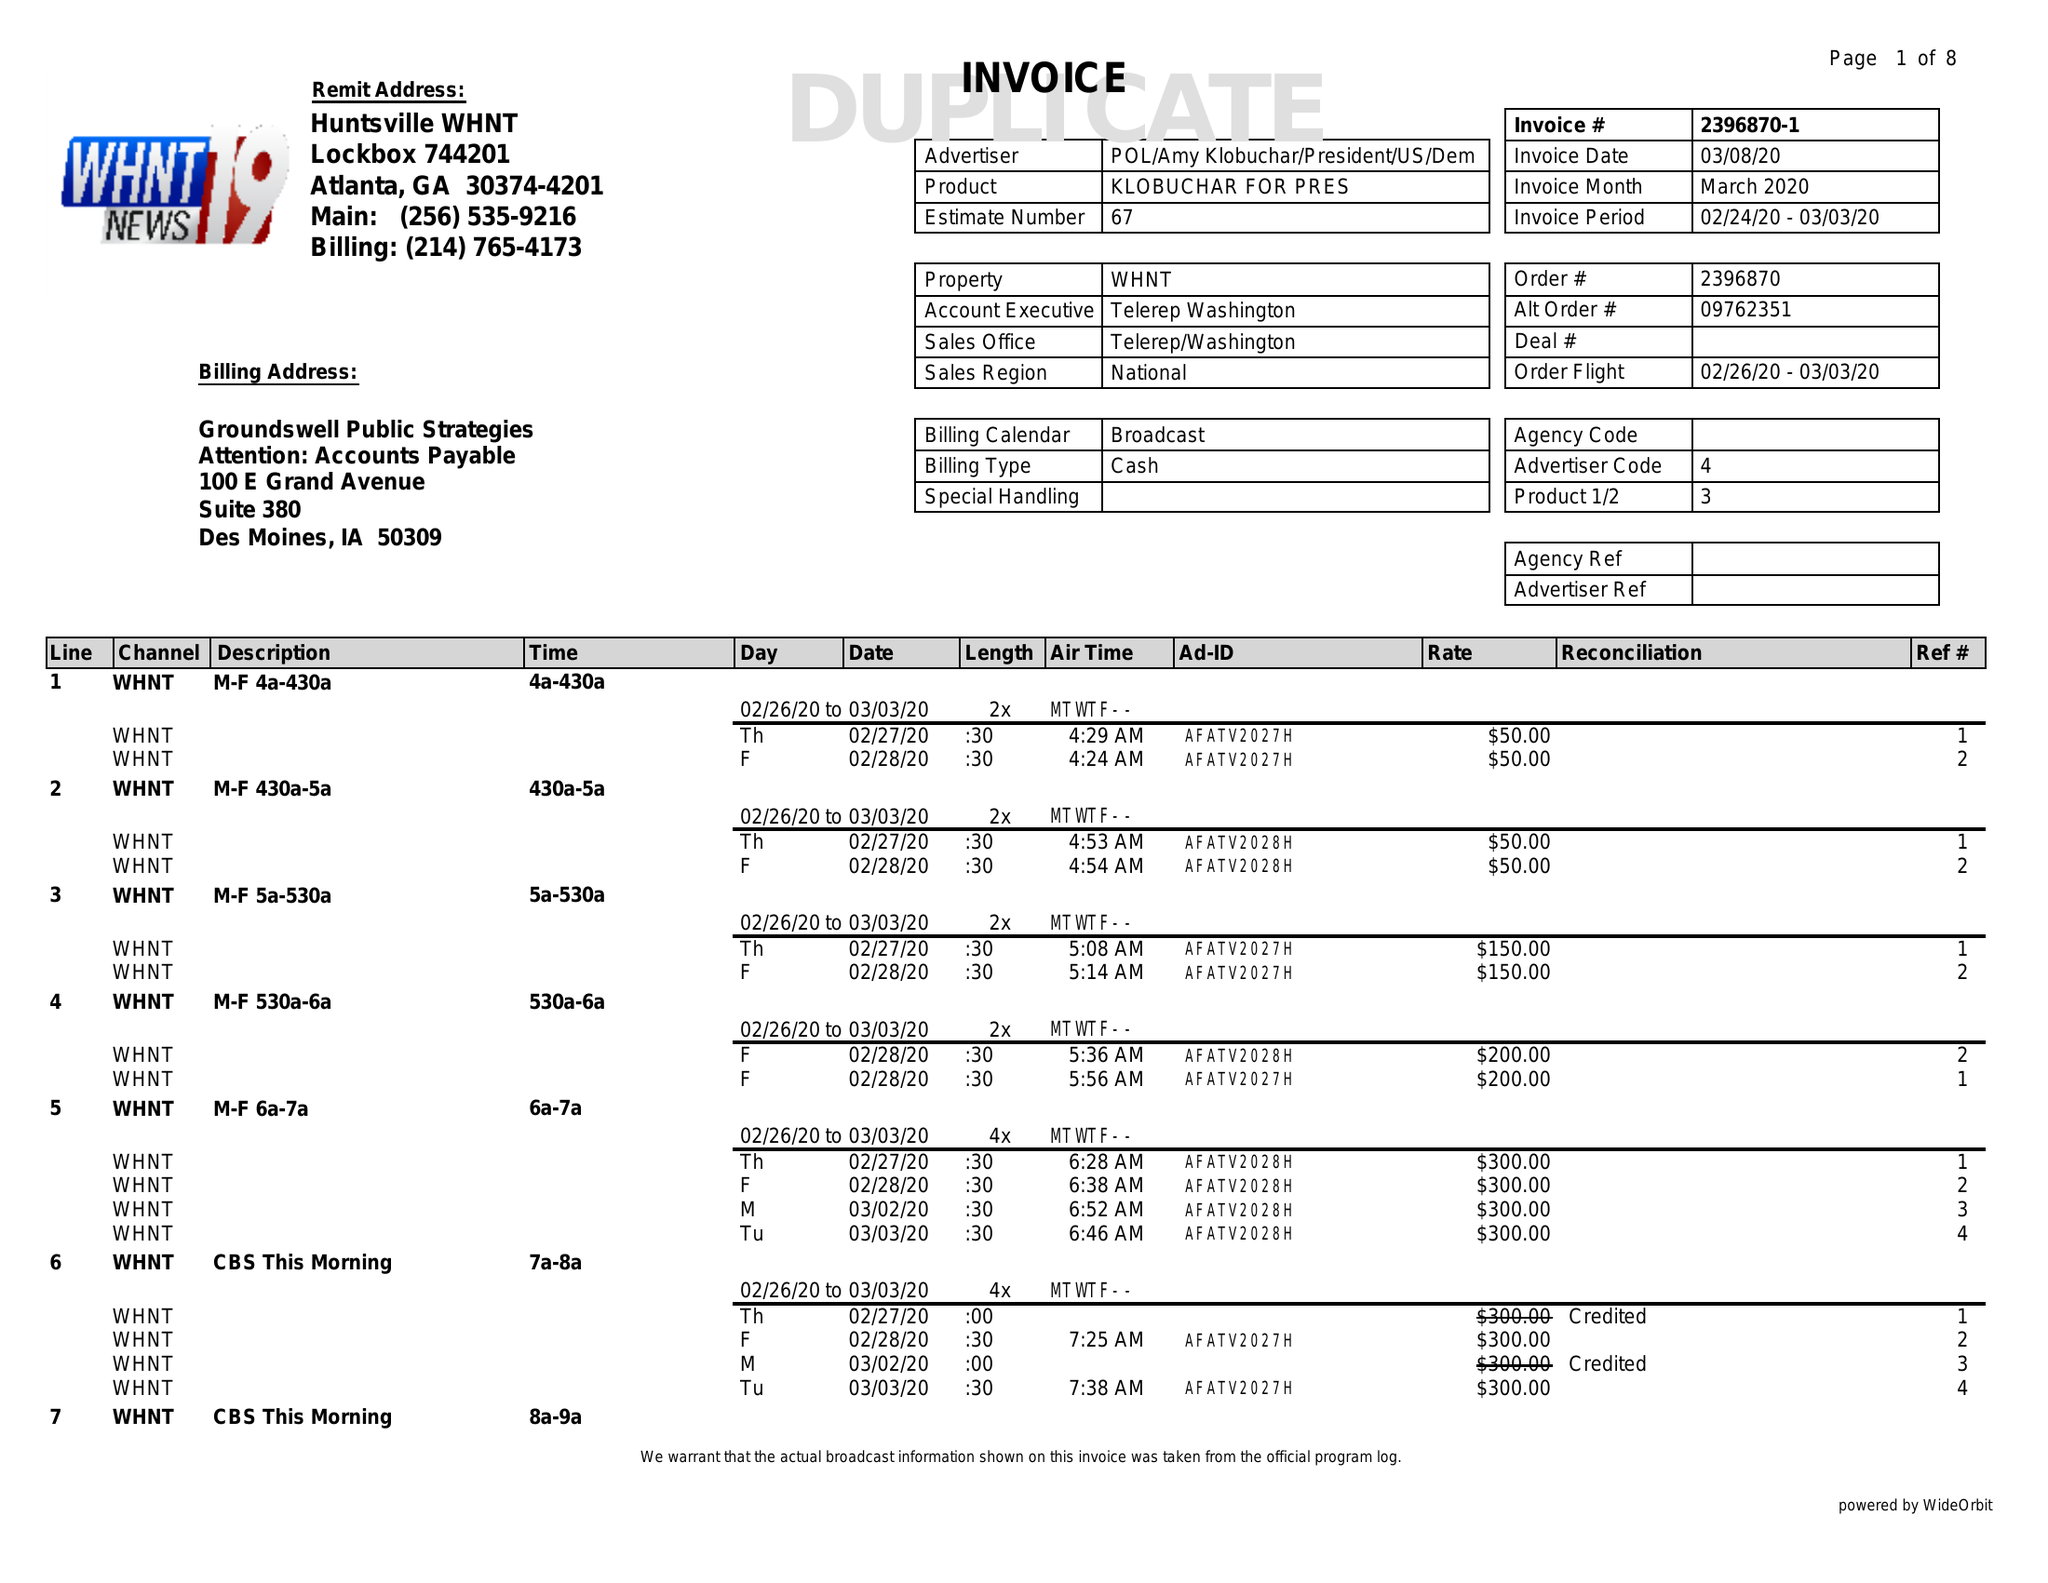What is the value for the advertiser?
Answer the question using a single word or phrase. POL/AMYKLOBUCHAR/PRESIDENT/US/DEM 